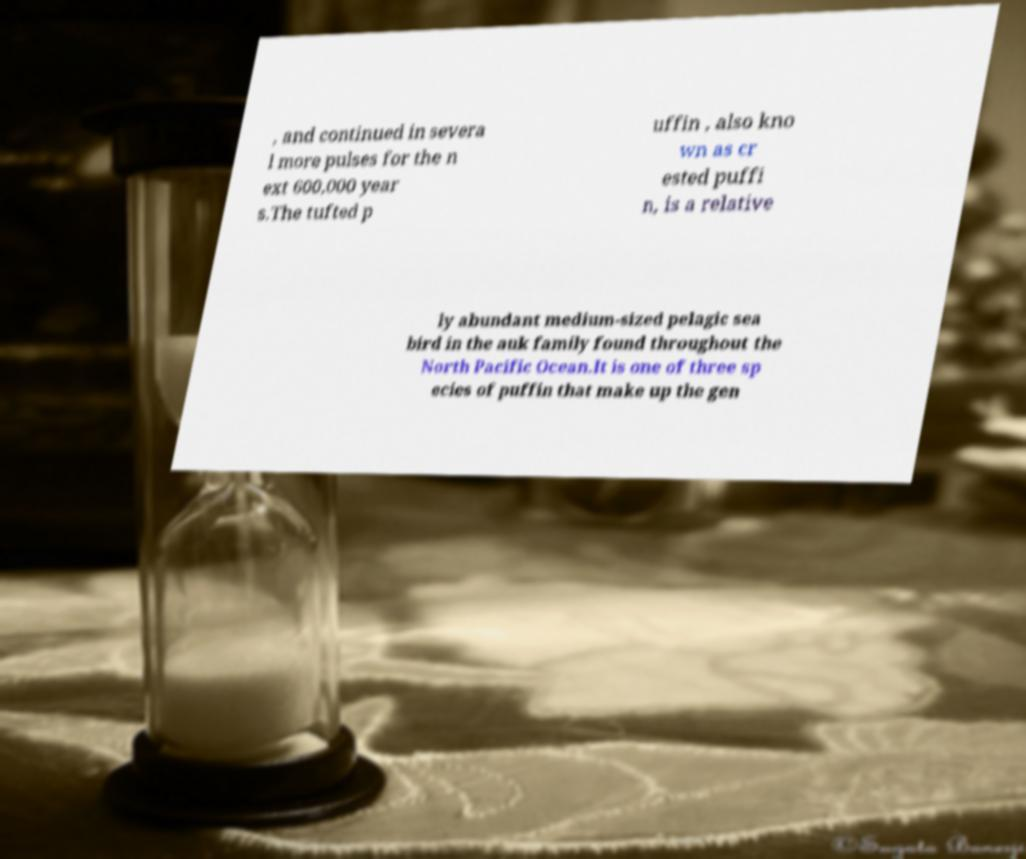Can you accurately transcribe the text from the provided image for me? , and continued in severa l more pulses for the n ext 600,000 year s.The tufted p uffin , also kno wn as cr ested puffi n, is a relative ly abundant medium-sized pelagic sea bird in the auk family found throughout the North Pacific Ocean.It is one of three sp ecies of puffin that make up the gen 